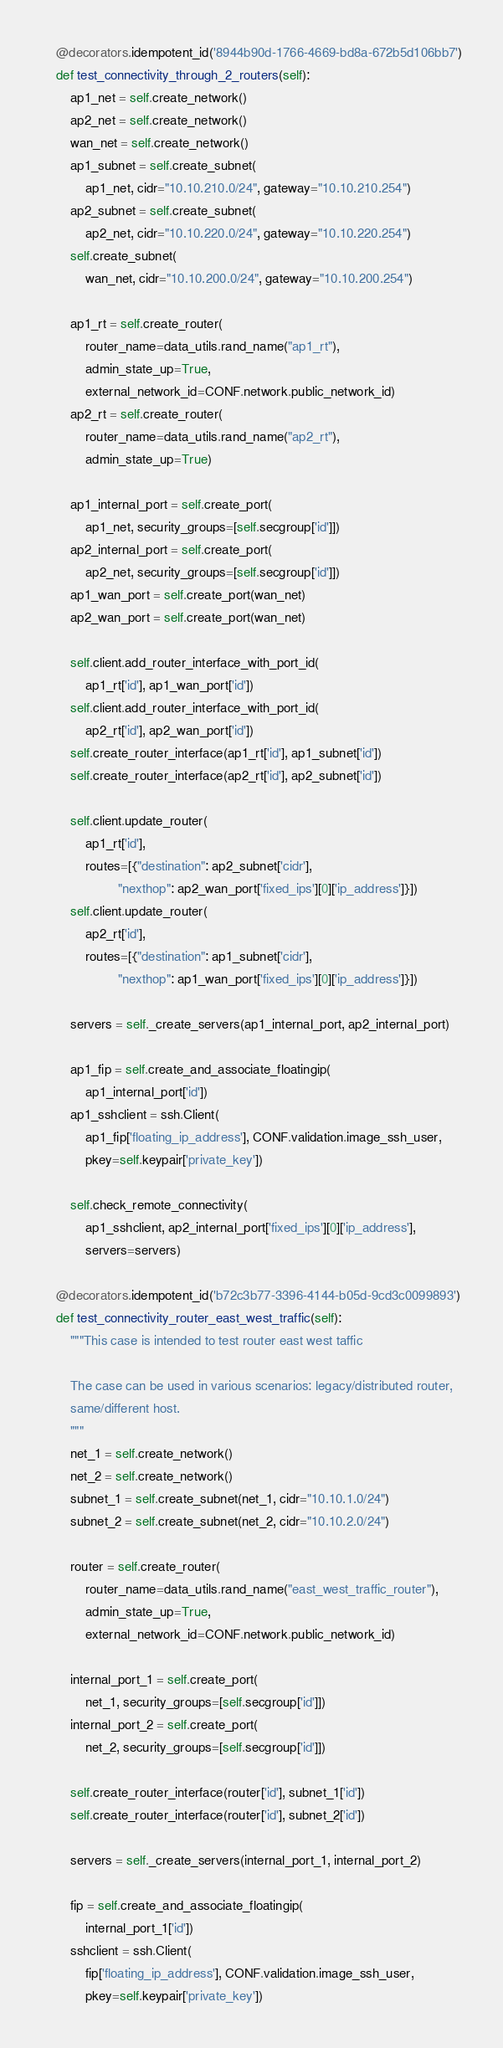<code> <loc_0><loc_0><loc_500><loc_500><_Python_>    @decorators.idempotent_id('8944b90d-1766-4669-bd8a-672b5d106bb7')
    def test_connectivity_through_2_routers(self):
        ap1_net = self.create_network()
        ap2_net = self.create_network()
        wan_net = self.create_network()
        ap1_subnet = self.create_subnet(
            ap1_net, cidr="10.10.210.0/24", gateway="10.10.210.254")
        ap2_subnet = self.create_subnet(
            ap2_net, cidr="10.10.220.0/24", gateway="10.10.220.254")
        self.create_subnet(
            wan_net, cidr="10.10.200.0/24", gateway="10.10.200.254")

        ap1_rt = self.create_router(
            router_name=data_utils.rand_name("ap1_rt"),
            admin_state_up=True,
            external_network_id=CONF.network.public_network_id)
        ap2_rt = self.create_router(
            router_name=data_utils.rand_name("ap2_rt"),
            admin_state_up=True)

        ap1_internal_port = self.create_port(
            ap1_net, security_groups=[self.secgroup['id']])
        ap2_internal_port = self.create_port(
            ap2_net, security_groups=[self.secgroup['id']])
        ap1_wan_port = self.create_port(wan_net)
        ap2_wan_port = self.create_port(wan_net)

        self.client.add_router_interface_with_port_id(
            ap1_rt['id'], ap1_wan_port['id'])
        self.client.add_router_interface_with_port_id(
            ap2_rt['id'], ap2_wan_port['id'])
        self.create_router_interface(ap1_rt['id'], ap1_subnet['id'])
        self.create_router_interface(ap2_rt['id'], ap2_subnet['id'])

        self.client.update_router(
            ap1_rt['id'],
            routes=[{"destination": ap2_subnet['cidr'],
                     "nexthop": ap2_wan_port['fixed_ips'][0]['ip_address']}])
        self.client.update_router(
            ap2_rt['id'],
            routes=[{"destination": ap1_subnet['cidr'],
                     "nexthop": ap1_wan_port['fixed_ips'][0]['ip_address']}])

        servers = self._create_servers(ap1_internal_port, ap2_internal_port)

        ap1_fip = self.create_and_associate_floatingip(
            ap1_internal_port['id'])
        ap1_sshclient = ssh.Client(
            ap1_fip['floating_ip_address'], CONF.validation.image_ssh_user,
            pkey=self.keypair['private_key'])

        self.check_remote_connectivity(
            ap1_sshclient, ap2_internal_port['fixed_ips'][0]['ip_address'],
            servers=servers)

    @decorators.idempotent_id('b72c3b77-3396-4144-b05d-9cd3c0099893')
    def test_connectivity_router_east_west_traffic(self):
        """This case is intended to test router east west taffic

        The case can be used in various scenarios: legacy/distributed router,
        same/different host.
        """
        net_1 = self.create_network()
        net_2 = self.create_network()
        subnet_1 = self.create_subnet(net_1, cidr="10.10.1.0/24")
        subnet_2 = self.create_subnet(net_2, cidr="10.10.2.0/24")

        router = self.create_router(
            router_name=data_utils.rand_name("east_west_traffic_router"),
            admin_state_up=True,
            external_network_id=CONF.network.public_network_id)

        internal_port_1 = self.create_port(
            net_1, security_groups=[self.secgroup['id']])
        internal_port_2 = self.create_port(
            net_2, security_groups=[self.secgroup['id']])

        self.create_router_interface(router['id'], subnet_1['id'])
        self.create_router_interface(router['id'], subnet_2['id'])

        servers = self._create_servers(internal_port_1, internal_port_2)

        fip = self.create_and_associate_floatingip(
            internal_port_1['id'])
        sshclient = ssh.Client(
            fip['floating_ip_address'], CONF.validation.image_ssh_user,
            pkey=self.keypair['private_key'])
</code> 